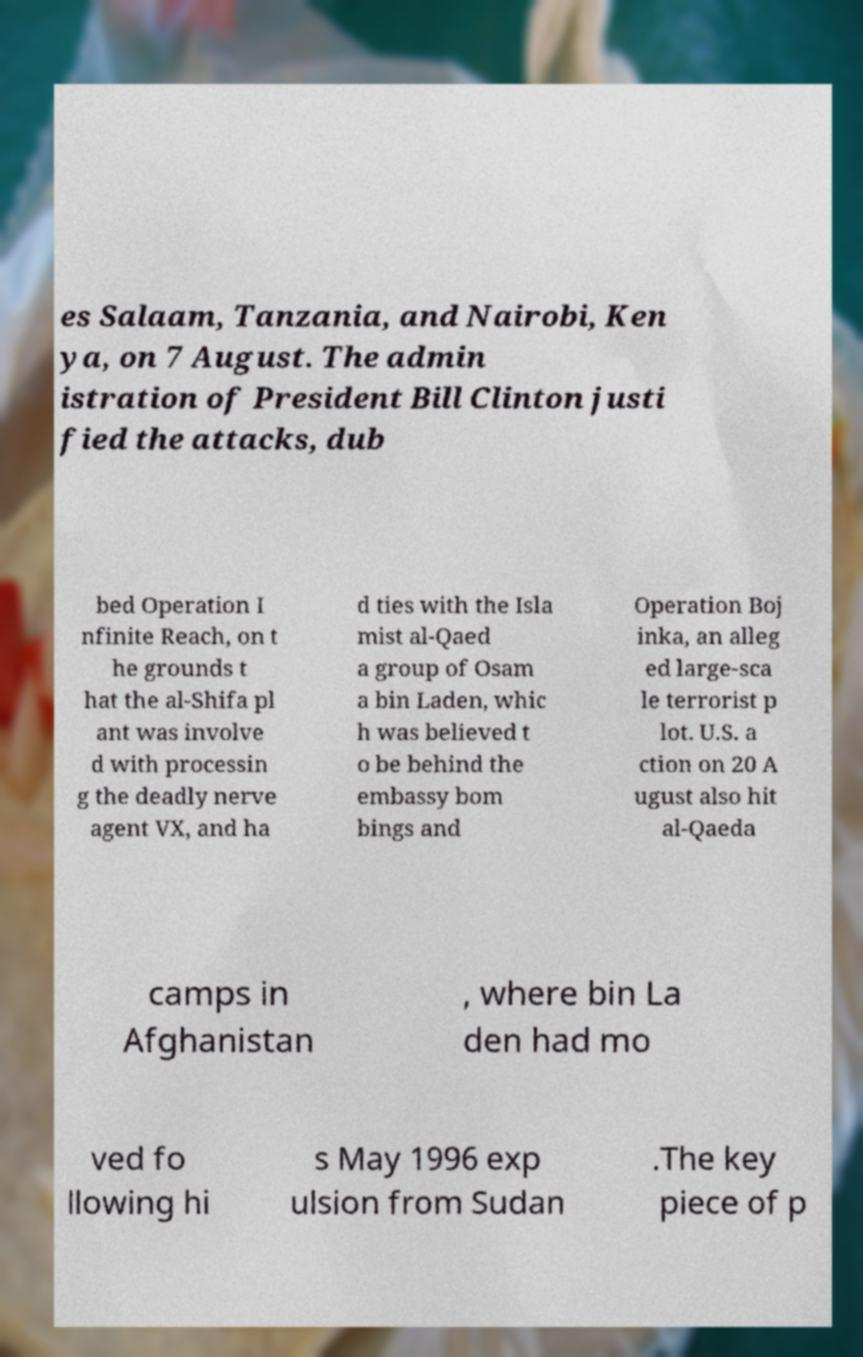Can you read and provide the text displayed in the image?This photo seems to have some interesting text. Can you extract and type it out for me? es Salaam, Tanzania, and Nairobi, Ken ya, on 7 August. The admin istration of President Bill Clinton justi fied the attacks, dub bed Operation I nfinite Reach, on t he grounds t hat the al-Shifa pl ant was involve d with processin g the deadly nerve agent VX, and ha d ties with the Isla mist al-Qaed a group of Osam a bin Laden, whic h was believed t o be behind the embassy bom bings and Operation Boj inka, an alleg ed large-sca le terrorist p lot. U.S. a ction on 20 A ugust also hit al-Qaeda camps in Afghanistan , where bin La den had mo ved fo llowing hi s May 1996 exp ulsion from Sudan .The key piece of p 